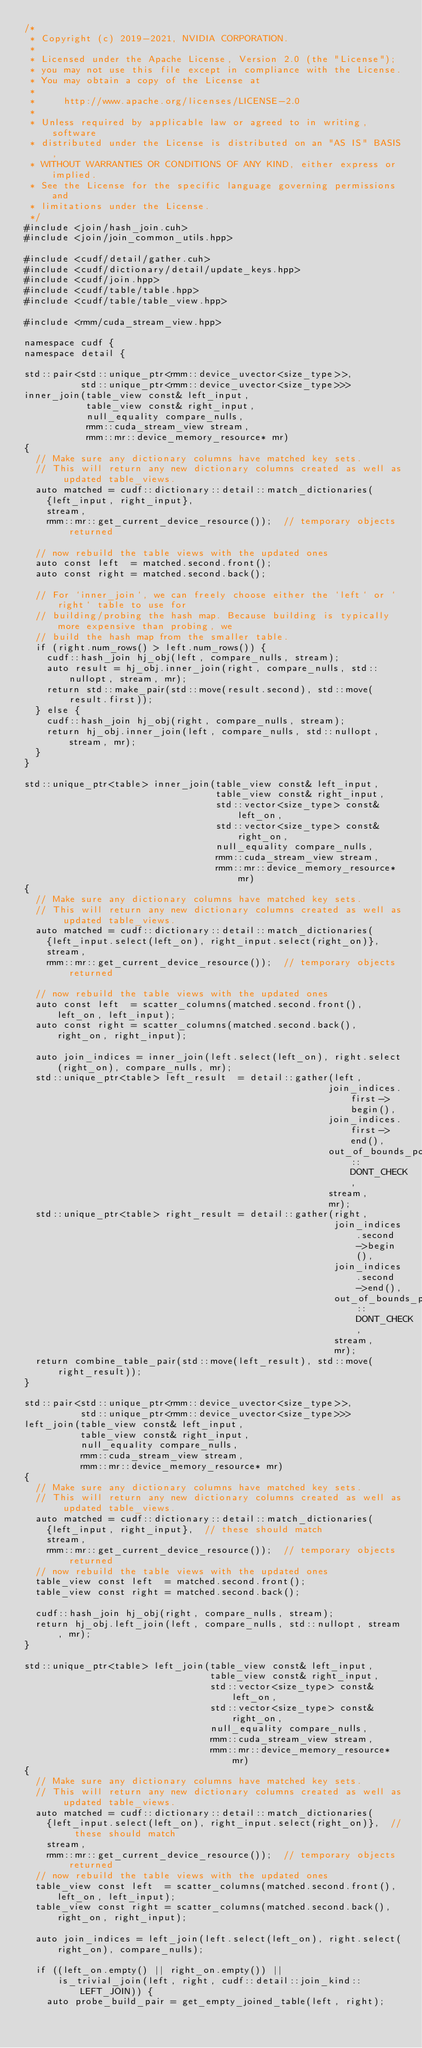<code> <loc_0><loc_0><loc_500><loc_500><_Cuda_>/*
 * Copyright (c) 2019-2021, NVIDIA CORPORATION.
 *
 * Licensed under the Apache License, Version 2.0 (the "License");
 * you may not use this file except in compliance with the License.
 * You may obtain a copy of the License at
 *
 *     http://www.apache.org/licenses/LICENSE-2.0
 *
 * Unless required by applicable law or agreed to in writing, software
 * distributed under the License is distributed on an "AS IS" BASIS,
 * WITHOUT WARRANTIES OR CONDITIONS OF ANY KIND, either express or implied.
 * See the License for the specific language governing permissions and
 * limitations under the License.
 */
#include <join/hash_join.cuh>
#include <join/join_common_utils.hpp>

#include <cudf/detail/gather.cuh>
#include <cudf/dictionary/detail/update_keys.hpp>
#include <cudf/join.hpp>
#include <cudf/table/table.hpp>
#include <cudf/table/table_view.hpp>

#include <rmm/cuda_stream_view.hpp>

namespace cudf {
namespace detail {

std::pair<std::unique_ptr<rmm::device_uvector<size_type>>,
          std::unique_ptr<rmm::device_uvector<size_type>>>
inner_join(table_view const& left_input,
           table_view const& right_input,
           null_equality compare_nulls,
           rmm::cuda_stream_view stream,
           rmm::mr::device_memory_resource* mr)
{
  // Make sure any dictionary columns have matched key sets.
  // This will return any new dictionary columns created as well as updated table_views.
  auto matched = cudf::dictionary::detail::match_dictionaries(
    {left_input, right_input},
    stream,
    rmm::mr::get_current_device_resource());  // temporary objects returned

  // now rebuild the table views with the updated ones
  auto const left  = matched.second.front();
  auto const right = matched.second.back();

  // For `inner_join`, we can freely choose either the `left` or `right` table to use for
  // building/probing the hash map. Because building is typically more expensive than probing, we
  // build the hash map from the smaller table.
  if (right.num_rows() > left.num_rows()) {
    cudf::hash_join hj_obj(left, compare_nulls, stream);
    auto result = hj_obj.inner_join(right, compare_nulls, std::nullopt, stream, mr);
    return std::make_pair(std::move(result.second), std::move(result.first));
  } else {
    cudf::hash_join hj_obj(right, compare_nulls, stream);
    return hj_obj.inner_join(left, compare_nulls, std::nullopt, stream, mr);
  }
}

std::unique_ptr<table> inner_join(table_view const& left_input,
                                  table_view const& right_input,
                                  std::vector<size_type> const& left_on,
                                  std::vector<size_type> const& right_on,
                                  null_equality compare_nulls,
                                  rmm::cuda_stream_view stream,
                                  rmm::mr::device_memory_resource* mr)
{
  // Make sure any dictionary columns have matched key sets.
  // This will return any new dictionary columns created as well as updated table_views.
  auto matched = cudf::dictionary::detail::match_dictionaries(
    {left_input.select(left_on), right_input.select(right_on)},
    stream,
    rmm::mr::get_current_device_resource());  // temporary objects returned

  // now rebuild the table views with the updated ones
  auto const left  = scatter_columns(matched.second.front(), left_on, left_input);
  auto const right = scatter_columns(matched.second.back(), right_on, right_input);

  auto join_indices = inner_join(left.select(left_on), right.select(right_on), compare_nulls, mr);
  std::unique_ptr<table> left_result  = detail::gather(left,
                                                      join_indices.first->begin(),
                                                      join_indices.first->end(),
                                                      out_of_bounds_policy::DONT_CHECK,
                                                      stream,
                                                      mr);
  std::unique_ptr<table> right_result = detail::gather(right,
                                                       join_indices.second->begin(),
                                                       join_indices.second->end(),
                                                       out_of_bounds_policy::DONT_CHECK,
                                                       stream,
                                                       mr);
  return combine_table_pair(std::move(left_result), std::move(right_result));
}

std::pair<std::unique_ptr<rmm::device_uvector<size_type>>,
          std::unique_ptr<rmm::device_uvector<size_type>>>
left_join(table_view const& left_input,
          table_view const& right_input,
          null_equality compare_nulls,
          rmm::cuda_stream_view stream,
          rmm::mr::device_memory_resource* mr)
{
  // Make sure any dictionary columns have matched key sets.
  // This will return any new dictionary columns created as well as updated table_views.
  auto matched = cudf::dictionary::detail::match_dictionaries(
    {left_input, right_input},  // these should match
    stream,
    rmm::mr::get_current_device_resource());  // temporary objects returned
  // now rebuild the table views with the updated ones
  table_view const left  = matched.second.front();
  table_view const right = matched.second.back();

  cudf::hash_join hj_obj(right, compare_nulls, stream);
  return hj_obj.left_join(left, compare_nulls, std::nullopt, stream, mr);
}

std::unique_ptr<table> left_join(table_view const& left_input,
                                 table_view const& right_input,
                                 std::vector<size_type> const& left_on,
                                 std::vector<size_type> const& right_on,
                                 null_equality compare_nulls,
                                 rmm::cuda_stream_view stream,
                                 rmm::mr::device_memory_resource* mr)
{
  // Make sure any dictionary columns have matched key sets.
  // This will return any new dictionary columns created as well as updated table_views.
  auto matched = cudf::dictionary::detail::match_dictionaries(
    {left_input.select(left_on), right_input.select(right_on)},  // these should match
    stream,
    rmm::mr::get_current_device_resource());  // temporary objects returned
  // now rebuild the table views with the updated ones
  table_view const left  = scatter_columns(matched.second.front(), left_on, left_input);
  table_view const right = scatter_columns(matched.second.back(), right_on, right_input);

  auto join_indices = left_join(left.select(left_on), right.select(right_on), compare_nulls);

  if ((left_on.empty() || right_on.empty()) ||
      is_trivial_join(left, right, cudf::detail::join_kind::LEFT_JOIN)) {
    auto probe_build_pair = get_empty_joined_table(left, right);</code> 